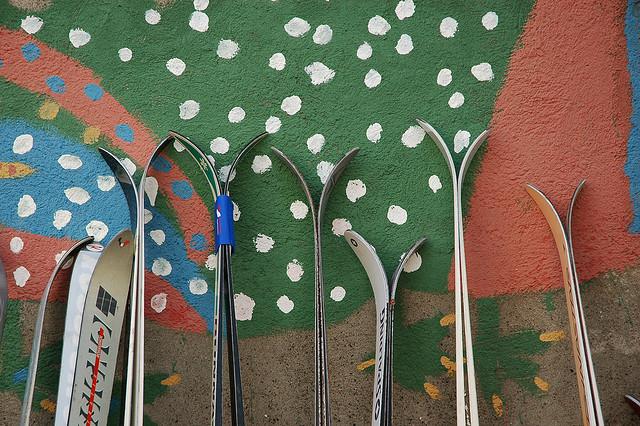What are these?
Quick response, please. Skis. Where do you ski?
Answer briefly. Snow. What color spots are on the green section?
Be succinct. White. 